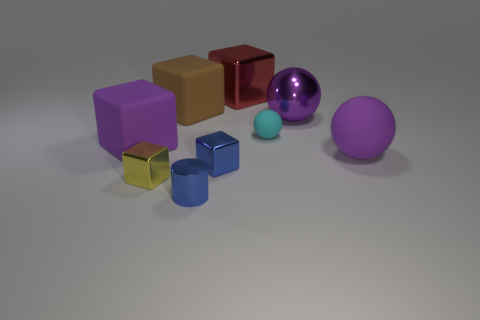There is a large brown thing that is made of the same material as the tiny sphere; what is its shape?
Provide a succinct answer. Cube. There is a blue thing behind the blue cylinder; is it the same size as the purple rubber cube?
Your answer should be compact. No. There is a tiny thing that is right of the tiny metal thing that is behind the small yellow object; what shape is it?
Offer a terse response. Sphere. How big is the ball behind the tiny thing that is on the right side of the red shiny thing?
Provide a succinct answer. Large. What is the color of the big metallic thing on the left side of the large purple metal ball?
Your answer should be very brief. Red. There is a cyan ball that is the same material as the large purple cube; what size is it?
Provide a short and direct response. Small. What number of cyan rubber things have the same shape as the purple metallic object?
Give a very brief answer. 1. There is a cylinder that is the same size as the yellow cube; what is it made of?
Make the answer very short. Metal. Are there any yellow blocks made of the same material as the tiny blue cylinder?
Provide a succinct answer. Yes. There is a cube that is in front of the red metallic object and behind the big shiny ball; what color is it?
Keep it short and to the point. Brown. 